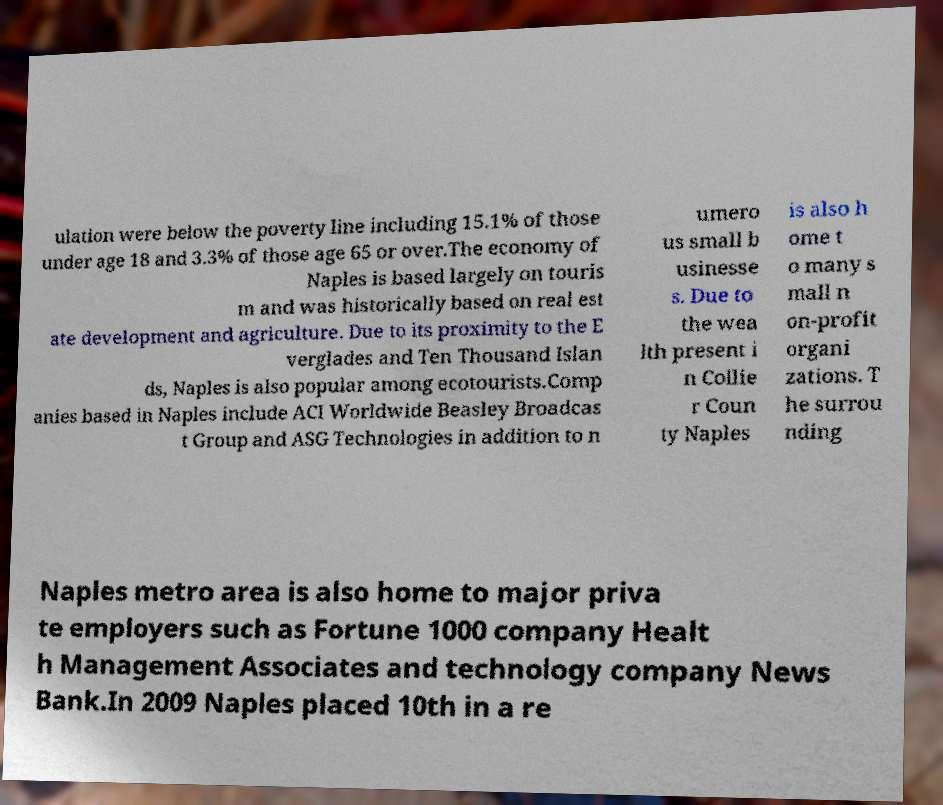I need the written content from this picture converted into text. Can you do that? ulation were below the poverty line including 15.1% of those under age 18 and 3.3% of those age 65 or over.The economy of Naples is based largely on touris m and was historically based on real est ate development and agriculture. Due to its proximity to the E verglades and Ten Thousand Islan ds, Naples is also popular among ecotourists.Comp anies based in Naples include ACI Worldwide Beasley Broadcas t Group and ASG Technologies in addition to n umero us small b usinesse s. Due to the wea lth present i n Collie r Coun ty Naples is also h ome t o many s mall n on-profit organi zations. T he surrou nding Naples metro area is also home to major priva te employers such as Fortune 1000 company Healt h Management Associates and technology company News Bank.In 2009 Naples placed 10th in a re 